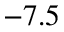<formula> <loc_0><loc_0><loc_500><loc_500>- 7 . 5</formula> 